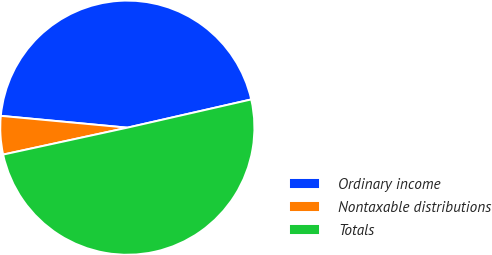<chart> <loc_0><loc_0><loc_500><loc_500><pie_chart><fcel>Ordinary income<fcel>Nontaxable distributions<fcel>Totals<nl><fcel>44.95%<fcel>4.88%<fcel>50.17%<nl></chart> 